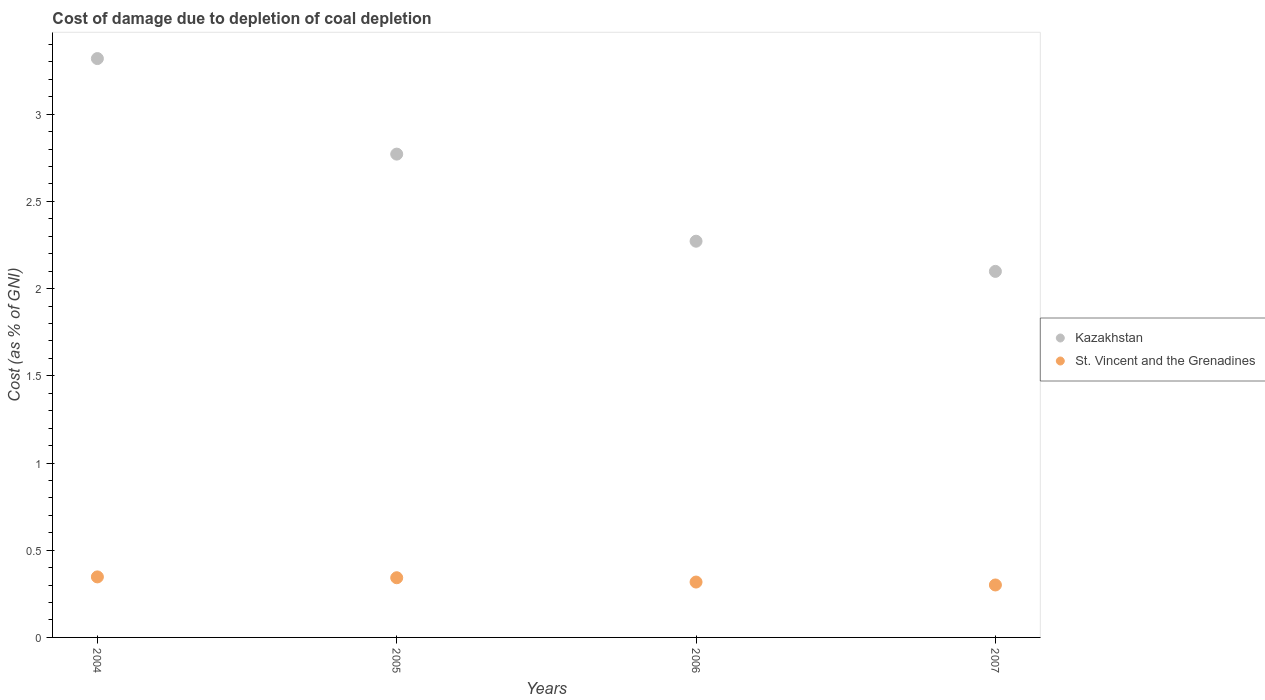How many different coloured dotlines are there?
Your answer should be compact. 2. Is the number of dotlines equal to the number of legend labels?
Make the answer very short. Yes. What is the cost of damage caused due to coal depletion in St. Vincent and the Grenadines in 2005?
Provide a succinct answer. 0.34. Across all years, what is the maximum cost of damage caused due to coal depletion in St. Vincent and the Grenadines?
Your answer should be very brief. 0.35. Across all years, what is the minimum cost of damage caused due to coal depletion in Kazakhstan?
Give a very brief answer. 2.1. In which year was the cost of damage caused due to coal depletion in Kazakhstan maximum?
Your answer should be very brief. 2004. What is the total cost of damage caused due to coal depletion in Kazakhstan in the graph?
Your answer should be compact. 10.46. What is the difference between the cost of damage caused due to coal depletion in St. Vincent and the Grenadines in 2004 and that in 2007?
Provide a succinct answer. 0.05. What is the difference between the cost of damage caused due to coal depletion in Kazakhstan in 2004 and the cost of damage caused due to coal depletion in St. Vincent and the Grenadines in 2007?
Keep it short and to the point. 3.02. What is the average cost of damage caused due to coal depletion in St. Vincent and the Grenadines per year?
Provide a short and direct response. 0.33. In the year 2006, what is the difference between the cost of damage caused due to coal depletion in St. Vincent and the Grenadines and cost of damage caused due to coal depletion in Kazakhstan?
Keep it short and to the point. -1.95. In how many years, is the cost of damage caused due to coal depletion in Kazakhstan greater than 1.2 %?
Provide a short and direct response. 4. What is the ratio of the cost of damage caused due to coal depletion in St. Vincent and the Grenadines in 2005 to that in 2006?
Your answer should be very brief. 1.08. What is the difference between the highest and the second highest cost of damage caused due to coal depletion in St. Vincent and the Grenadines?
Offer a very short reply. 0. What is the difference between the highest and the lowest cost of damage caused due to coal depletion in Kazakhstan?
Provide a succinct answer. 1.22. In how many years, is the cost of damage caused due to coal depletion in Kazakhstan greater than the average cost of damage caused due to coal depletion in Kazakhstan taken over all years?
Provide a short and direct response. 2. Is the sum of the cost of damage caused due to coal depletion in Kazakhstan in 2005 and 2007 greater than the maximum cost of damage caused due to coal depletion in St. Vincent and the Grenadines across all years?
Keep it short and to the point. Yes. Does the cost of damage caused due to coal depletion in St. Vincent and the Grenadines monotonically increase over the years?
Keep it short and to the point. No. Is the cost of damage caused due to coal depletion in St. Vincent and the Grenadines strictly less than the cost of damage caused due to coal depletion in Kazakhstan over the years?
Your answer should be very brief. Yes. What is the difference between two consecutive major ticks on the Y-axis?
Your answer should be compact. 0.5. Where does the legend appear in the graph?
Your response must be concise. Center right. How many legend labels are there?
Give a very brief answer. 2. What is the title of the graph?
Provide a short and direct response. Cost of damage due to depletion of coal depletion. What is the label or title of the X-axis?
Provide a short and direct response. Years. What is the label or title of the Y-axis?
Your answer should be compact. Cost (as % of GNI). What is the Cost (as % of GNI) in Kazakhstan in 2004?
Your answer should be very brief. 3.32. What is the Cost (as % of GNI) in St. Vincent and the Grenadines in 2004?
Provide a succinct answer. 0.35. What is the Cost (as % of GNI) in Kazakhstan in 2005?
Make the answer very short. 2.77. What is the Cost (as % of GNI) in St. Vincent and the Grenadines in 2005?
Offer a very short reply. 0.34. What is the Cost (as % of GNI) of Kazakhstan in 2006?
Provide a succinct answer. 2.27. What is the Cost (as % of GNI) in St. Vincent and the Grenadines in 2006?
Your response must be concise. 0.32. What is the Cost (as % of GNI) of Kazakhstan in 2007?
Offer a terse response. 2.1. What is the Cost (as % of GNI) in St. Vincent and the Grenadines in 2007?
Give a very brief answer. 0.3. Across all years, what is the maximum Cost (as % of GNI) of Kazakhstan?
Provide a short and direct response. 3.32. Across all years, what is the maximum Cost (as % of GNI) in St. Vincent and the Grenadines?
Provide a short and direct response. 0.35. Across all years, what is the minimum Cost (as % of GNI) in Kazakhstan?
Offer a very short reply. 2.1. Across all years, what is the minimum Cost (as % of GNI) of St. Vincent and the Grenadines?
Your answer should be compact. 0.3. What is the total Cost (as % of GNI) in Kazakhstan in the graph?
Your response must be concise. 10.46. What is the total Cost (as % of GNI) in St. Vincent and the Grenadines in the graph?
Keep it short and to the point. 1.31. What is the difference between the Cost (as % of GNI) in Kazakhstan in 2004 and that in 2005?
Make the answer very short. 0.55. What is the difference between the Cost (as % of GNI) of St. Vincent and the Grenadines in 2004 and that in 2005?
Your response must be concise. 0. What is the difference between the Cost (as % of GNI) in Kazakhstan in 2004 and that in 2006?
Your answer should be very brief. 1.05. What is the difference between the Cost (as % of GNI) in St. Vincent and the Grenadines in 2004 and that in 2006?
Offer a very short reply. 0.03. What is the difference between the Cost (as % of GNI) of Kazakhstan in 2004 and that in 2007?
Give a very brief answer. 1.22. What is the difference between the Cost (as % of GNI) of St. Vincent and the Grenadines in 2004 and that in 2007?
Provide a short and direct response. 0.05. What is the difference between the Cost (as % of GNI) of Kazakhstan in 2005 and that in 2006?
Offer a very short reply. 0.5. What is the difference between the Cost (as % of GNI) in St. Vincent and the Grenadines in 2005 and that in 2006?
Your answer should be compact. 0.02. What is the difference between the Cost (as % of GNI) of Kazakhstan in 2005 and that in 2007?
Keep it short and to the point. 0.67. What is the difference between the Cost (as % of GNI) in St. Vincent and the Grenadines in 2005 and that in 2007?
Ensure brevity in your answer.  0.04. What is the difference between the Cost (as % of GNI) in Kazakhstan in 2006 and that in 2007?
Your response must be concise. 0.17. What is the difference between the Cost (as % of GNI) in St. Vincent and the Grenadines in 2006 and that in 2007?
Offer a terse response. 0.02. What is the difference between the Cost (as % of GNI) of Kazakhstan in 2004 and the Cost (as % of GNI) of St. Vincent and the Grenadines in 2005?
Give a very brief answer. 2.98. What is the difference between the Cost (as % of GNI) in Kazakhstan in 2004 and the Cost (as % of GNI) in St. Vincent and the Grenadines in 2006?
Offer a terse response. 3. What is the difference between the Cost (as % of GNI) in Kazakhstan in 2004 and the Cost (as % of GNI) in St. Vincent and the Grenadines in 2007?
Offer a terse response. 3.02. What is the difference between the Cost (as % of GNI) in Kazakhstan in 2005 and the Cost (as % of GNI) in St. Vincent and the Grenadines in 2006?
Provide a succinct answer. 2.45. What is the difference between the Cost (as % of GNI) of Kazakhstan in 2005 and the Cost (as % of GNI) of St. Vincent and the Grenadines in 2007?
Provide a short and direct response. 2.47. What is the difference between the Cost (as % of GNI) in Kazakhstan in 2006 and the Cost (as % of GNI) in St. Vincent and the Grenadines in 2007?
Your response must be concise. 1.97. What is the average Cost (as % of GNI) of Kazakhstan per year?
Offer a terse response. 2.62. What is the average Cost (as % of GNI) in St. Vincent and the Grenadines per year?
Ensure brevity in your answer.  0.33. In the year 2004, what is the difference between the Cost (as % of GNI) in Kazakhstan and Cost (as % of GNI) in St. Vincent and the Grenadines?
Ensure brevity in your answer.  2.97. In the year 2005, what is the difference between the Cost (as % of GNI) of Kazakhstan and Cost (as % of GNI) of St. Vincent and the Grenadines?
Provide a succinct answer. 2.43. In the year 2006, what is the difference between the Cost (as % of GNI) in Kazakhstan and Cost (as % of GNI) in St. Vincent and the Grenadines?
Your response must be concise. 1.95. In the year 2007, what is the difference between the Cost (as % of GNI) of Kazakhstan and Cost (as % of GNI) of St. Vincent and the Grenadines?
Offer a terse response. 1.8. What is the ratio of the Cost (as % of GNI) of Kazakhstan in 2004 to that in 2005?
Give a very brief answer. 1.2. What is the ratio of the Cost (as % of GNI) of St. Vincent and the Grenadines in 2004 to that in 2005?
Provide a succinct answer. 1.01. What is the ratio of the Cost (as % of GNI) of Kazakhstan in 2004 to that in 2006?
Give a very brief answer. 1.46. What is the ratio of the Cost (as % of GNI) of St. Vincent and the Grenadines in 2004 to that in 2006?
Keep it short and to the point. 1.09. What is the ratio of the Cost (as % of GNI) of Kazakhstan in 2004 to that in 2007?
Keep it short and to the point. 1.58. What is the ratio of the Cost (as % of GNI) in St. Vincent and the Grenadines in 2004 to that in 2007?
Keep it short and to the point. 1.15. What is the ratio of the Cost (as % of GNI) of Kazakhstan in 2005 to that in 2006?
Keep it short and to the point. 1.22. What is the ratio of the Cost (as % of GNI) of St. Vincent and the Grenadines in 2005 to that in 2006?
Offer a very short reply. 1.08. What is the ratio of the Cost (as % of GNI) of Kazakhstan in 2005 to that in 2007?
Your response must be concise. 1.32. What is the ratio of the Cost (as % of GNI) in St. Vincent and the Grenadines in 2005 to that in 2007?
Provide a succinct answer. 1.14. What is the ratio of the Cost (as % of GNI) of Kazakhstan in 2006 to that in 2007?
Provide a succinct answer. 1.08. What is the ratio of the Cost (as % of GNI) of St. Vincent and the Grenadines in 2006 to that in 2007?
Give a very brief answer. 1.06. What is the difference between the highest and the second highest Cost (as % of GNI) in Kazakhstan?
Your response must be concise. 0.55. What is the difference between the highest and the second highest Cost (as % of GNI) in St. Vincent and the Grenadines?
Provide a succinct answer. 0. What is the difference between the highest and the lowest Cost (as % of GNI) of Kazakhstan?
Provide a succinct answer. 1.22. What is the difference between the highest and the lowest Cost (as % of GNI) of St. Vincent and the Grenadines?
Give a very brief answer. 0.05. 